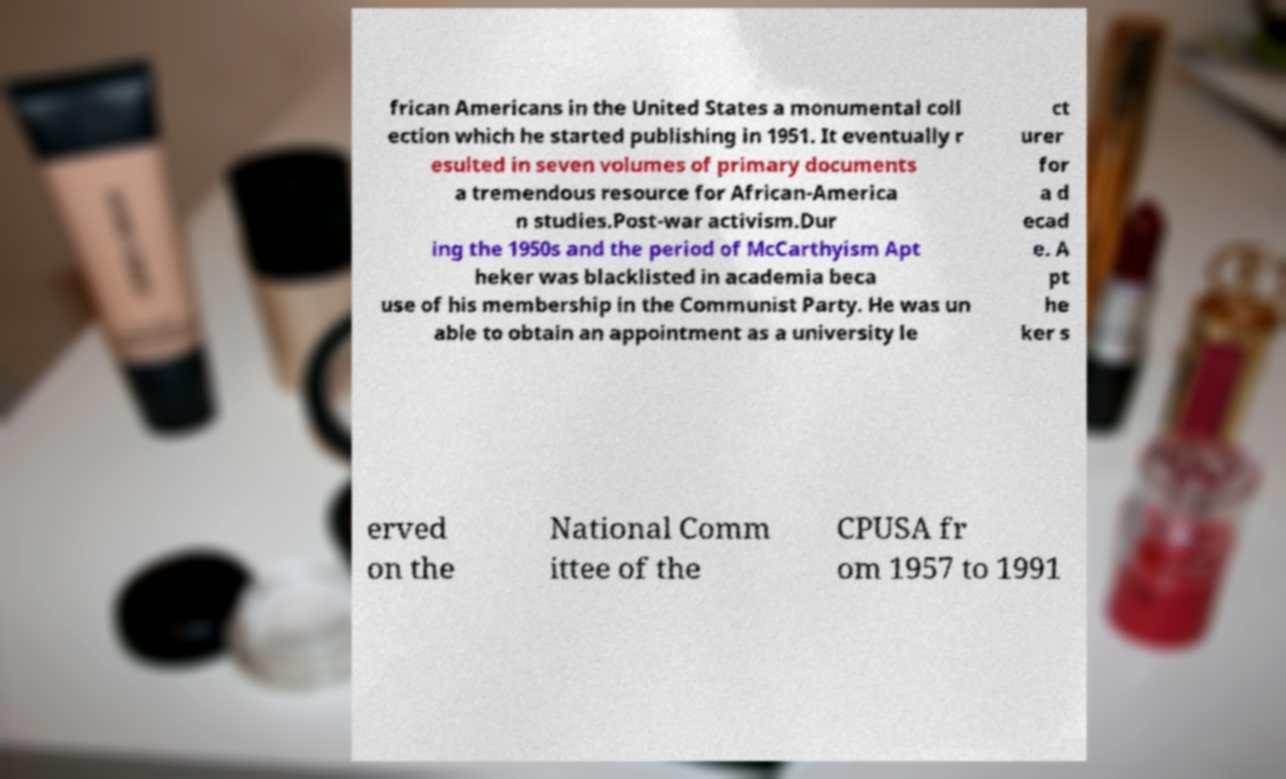Could you extract and type out the text from this image? frican Americans in the United States a monumental coll ection which he started publishing in 1951. It eventually r esulted in seven volumes of primary documents a tremendous resource for African-America n studies.Post-war activism.Dur ing the 1950s and the period of McCarthyism Apt heker was blacklisted in academia beca use of his membership in the Communist Party. He was un able to obtain an appointment as a university le ct urer for a d ecad e. A pt he ker s erved on the National Comm ittee of the CPUSA fr om 1957 to 1991 